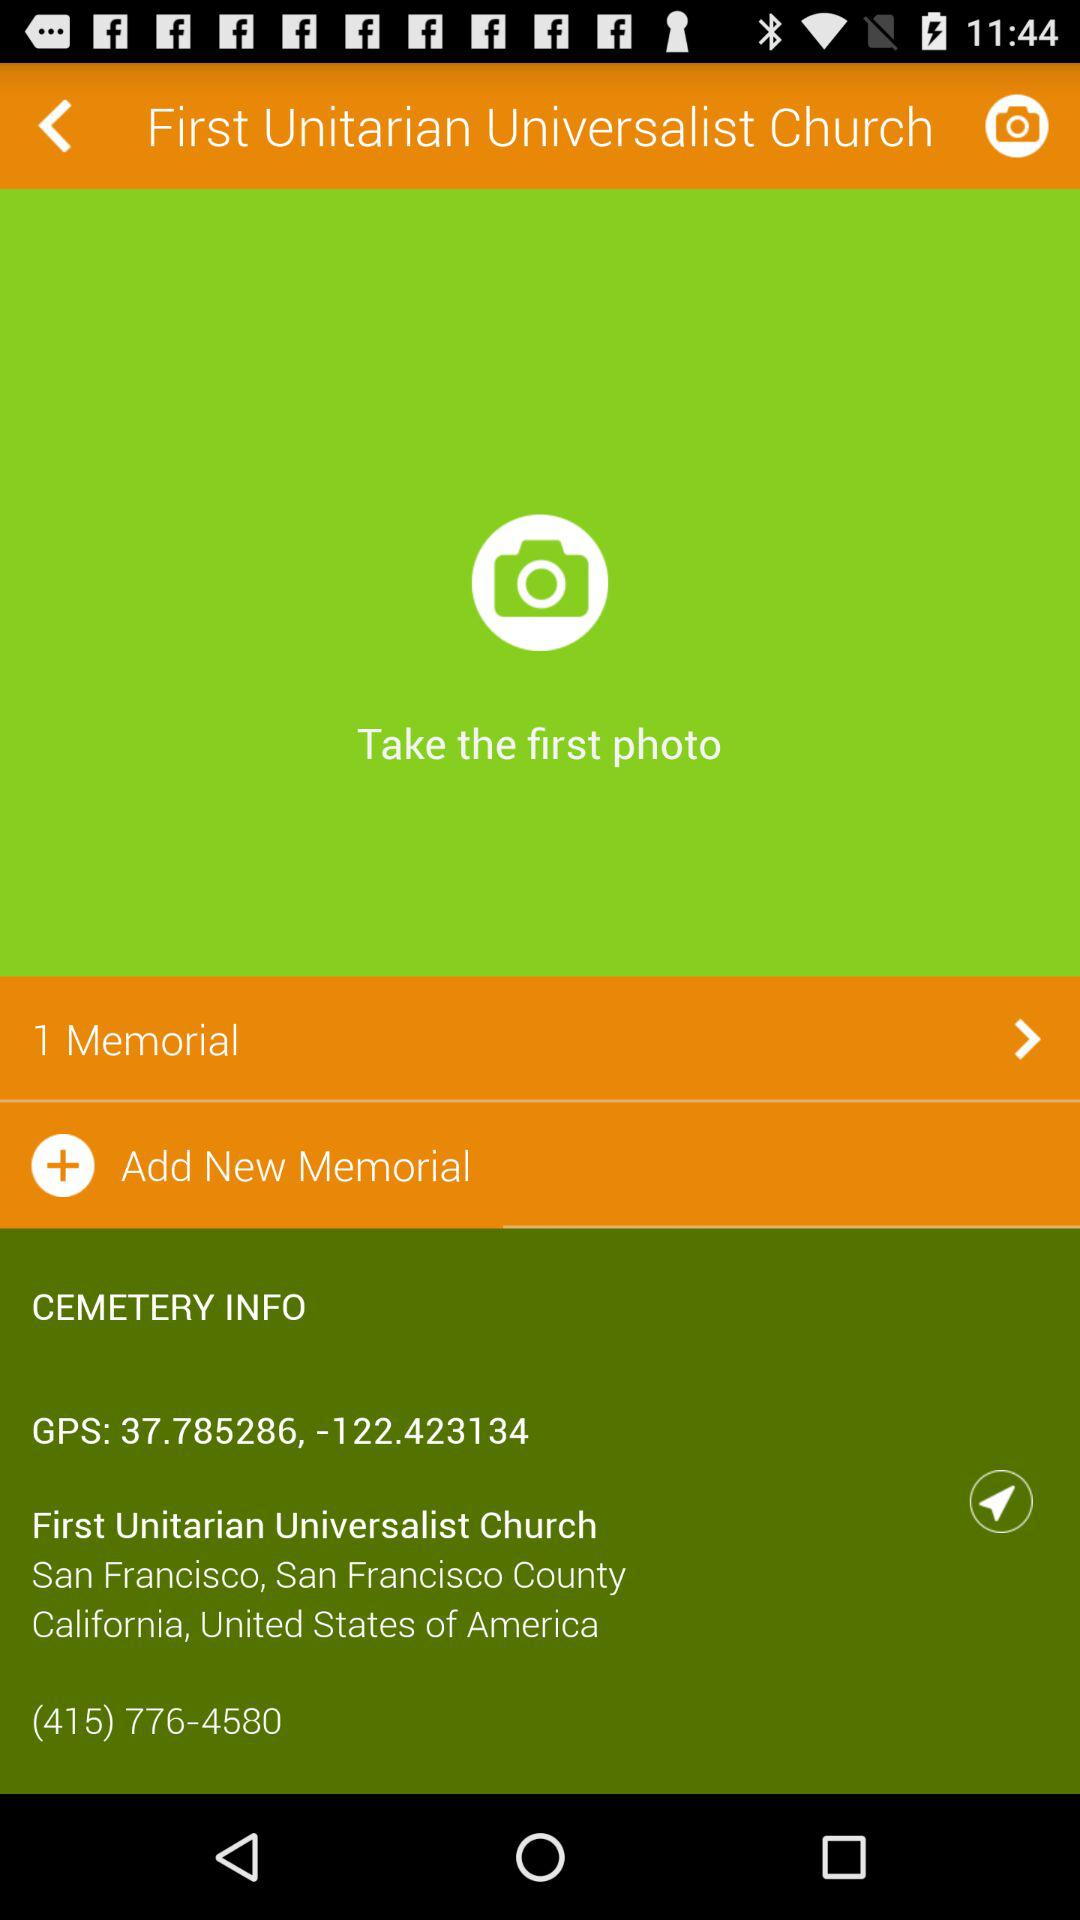What is the address of the First Unitarian Universalist Church? The address is San Francisco, San Francisco Country, California, United States of America. 